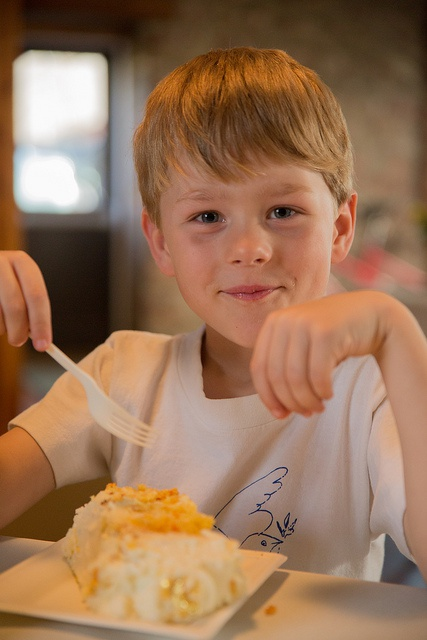Describe the objects in this image and their specific colors. I can see people in maroon, salmon, darkgray, and tan tones, cake in maroon, tan, and orange tones, dining table in maroon, gray, and tan tones, and fork in maroon and tan tones in this image. 